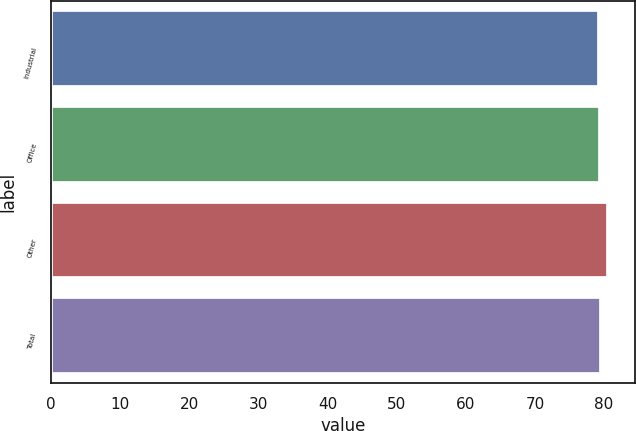Convert chart to OTSL. <chart><loc_0><loc_0><loc_500><loc_500><bar_chart><fcel>Industrial<fcel>Office<fcel>Other<fcel>Total<nl><fcel>79.3<fcel>79.42<fcel>80.5<fcel>79.54<nl></chart> 